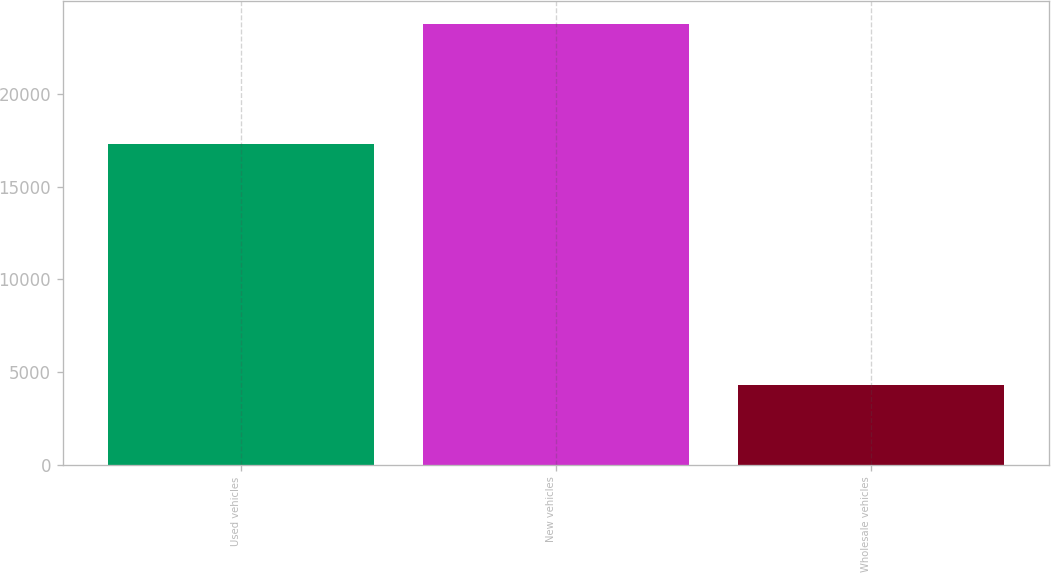<chart> <loc_0><loc_0><loc_500><loc_500><bar_chart><fcel>Used vehicles<fcel>New vehicles<fcel>Wholesale vehicles<nl><fcel>17298<fcel>23795<fcel>4319<nl></chart> 